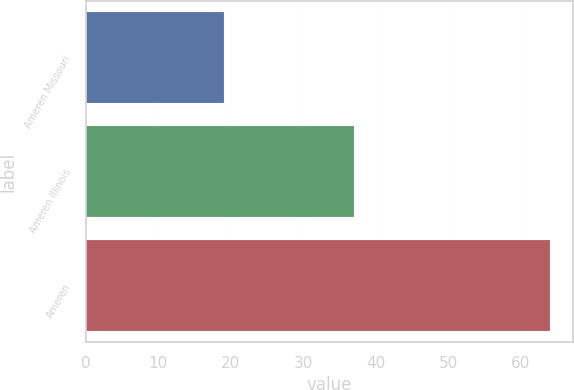Convert chart. <chart><loc_0><loc_0><loc_500><loc_500><bar_chart><fcel>Ameren Missouri<fcel>Ameren Illinois<fcel>Ameren<nl><fcel>19<fcel>37<fcel>64<nl></chart> 